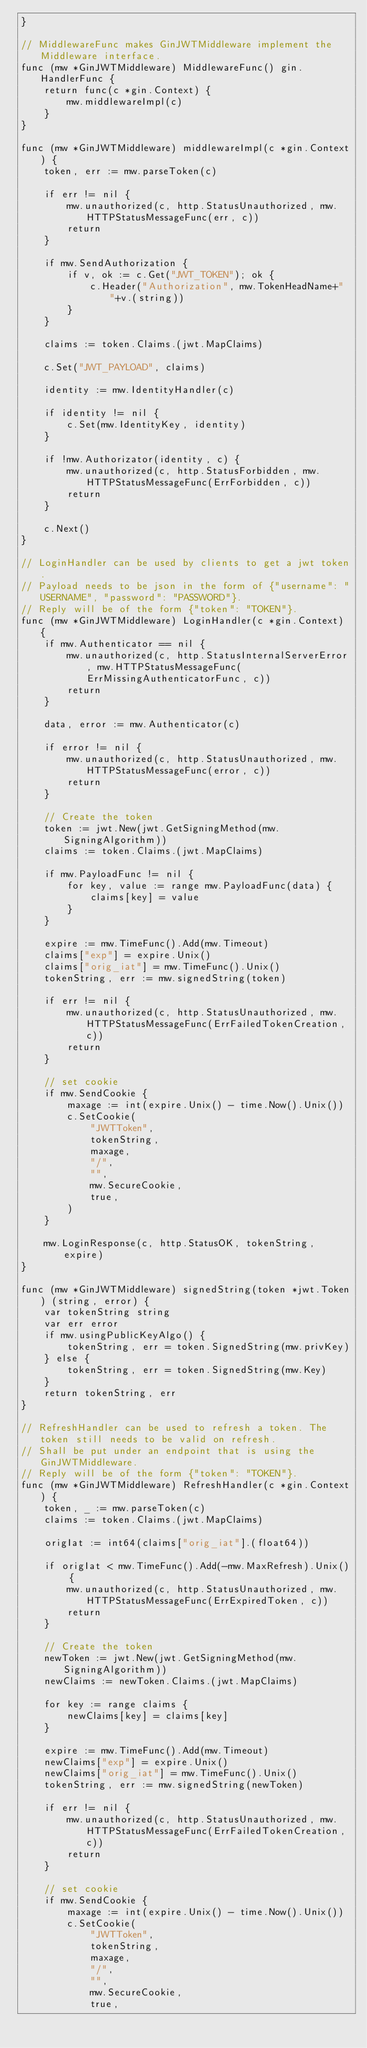Convert code to text. <code><loc_0><loc_0><loc_500><loc_500><_Go_>}

// MiddlewareFunc makes GinJWTMiddleware implement the Middleware interface.
func (mw *GinJWTMiddleware) MiddlewareFunc() gin.HandlerFunc {
	return func(c *gin.Context) {
		mw.middlewareImpl(c)
	}
}

func (mw *GinJWTMiddleware) middlewareImpl(c *gin.Context) {
	token, err := mw.parseToken(c)

	if err != nil {
		mw.unauthorized(c, http.StatusUnauthorized, mw.HTTPStatusMessageFunc(err, c))
		return
	}

	if mw.SendAuthorization {
		if v, ok := c.Get("JWT_TOKEN"); ok {
			c.Header("Authorization", mw.TokenHeadName+" "+v.(string))
		}
	}

	claims := token.Claims.(jwt.MapClaims)
	
	c.Set("JWT_PAYLOAD", claims)

	identity := mw.IdentityHandler(c)

	if identity != nil {
		c.Set(mw.IdentityKey, identity)
	}

	if !mw.Authorizator(identity, c) {
		mw.unauthorized(c, http.StatusForbidden, mw.HTTPStatusMessageFunc(ErrForbidden, c))
		return
	}

	c.Next()
}

// LoginHandler can be used by clients to get a jwt token.
// Payload needs to be json in the form of {"username": "USERNAME", "password": "PASSWORD"}.
// Reply will be of the form {"token": "TOKEN"}.
func (mw *GinJWTMiddleware) LoginHandler(c *gin.Context) {
	if mw.Authenticator == nil {
		mw.unauthorized(c, http.StatusInternalServerError, mw.HTTPStatusMessageFunc(ErrMissingAuthenticatorFunc, c))
		return
	}

	data, error := mw.Authenticator(c)

	if error != nil {
		mw.unauthorized(c, http.StatusUnauthorized, mw.HTTPStatusMessageFunc(error, c))
		return
	}

	// Create the token
	token := jwt.New(jwt.GetSigningMethod(mw.SigningAlgorithm))
	claims := token.Claims.(jwt.MapClaims)

	if mw.PayloadFunc != nil {
		for key, value := range mw.PayloadFunc(data) {
			claims[key] = value
		}
	}

	expire := mw.TimeFunc().Add(mw.Timeout)
	claims["exp"] = expire.Unix()
	claims["orig_iat"] = mw.TimeFunc().Unix()
	tokenString, err := mw.signedString(token)

	if err != nil {
		mw.unauthorized(c, http.StatusUnauthorized, mw.HTTPStatusMessageFunc(ErrFailedTokenCreation, c))
		return
	}

	// set cookie
	if mw.SendCookie {
		maxage := int(expire.Unix() - time.Now().Unix())
		c.SetCookie(
			"JWTToken",
			tokenString,
			maxage,
			"/",
			"",
			mw.SecureCookie,
			true,
		)
	}

	mw.LoginResponse(c, http.StatusOK, tokenString, expire)
}

func (mw *GinJWTMiddleware) signedString(token *jwt.Token) (string, error) {
	var tokenString string
	var err error
	if mw.usingPublicKeyAlgo() {
		tokenString, err = token.SignedString(mw.privKey)
	} else {
		tokenString, err = token.SignedString(mw.Key)
	}
	return tokenString, err
}

// RefreshHandler can be used to refresh a token. The token still needs to be valid on refresh.
// Shall be put under an endpoint that is using the GinJWTMiddleware.
// Reply will be of the form {"token": "TOKEN"}.
func (mw *GinJWTMiddleware) RefreshHandler(c *gin.Context) {
	token, _ := mw.parseToken(c)
	claims := token.Claims.(jwt.MapClaims)

	origIat := int64(claims["orig_iat"].(float64))

	if origIat < mw.TimeFunc().Add(-mw.MaxRefresh).Unix() {
		mw.unauthorized(c, http.StatusUnauthorized, mw.HTTPStatusMessageFunc(ErrExpiredToken, c))
		return
	}

	// Create the token
	newToken := jwt.New(jwt.GetSigningMethod(mw.SigningAlgorithm))
	newClaims := newToken.Claims.(jwt.MapClaims)

	for key := range claims {
		newClaims[key] = claims[key]
	}

	expire := mw.TimeFunc().Add(mw.Timeout)
	newClaims["exp"] = expire.Unix()
	newClaims["orig_iat"] = mw.TimeFunc().Unix()
	tokenString, err := mw.signedString(newToken)

	if err != nil {
		mw.unauthorized(c, http.StatusUnauthorized, mw.HTTPStatusMessageFunc(ErrFailedTokenCreation, c))
		return
	}

	// set cookie
	if mw.SendCookie {
		maxage := int(expire.Unix() - time.Now().Unix())
		c.SetCookie(
			"JWTToken",
			tokenString,
			maxage,
			"/",
			"",
			mw.SecureCookie,
			true,</code> 